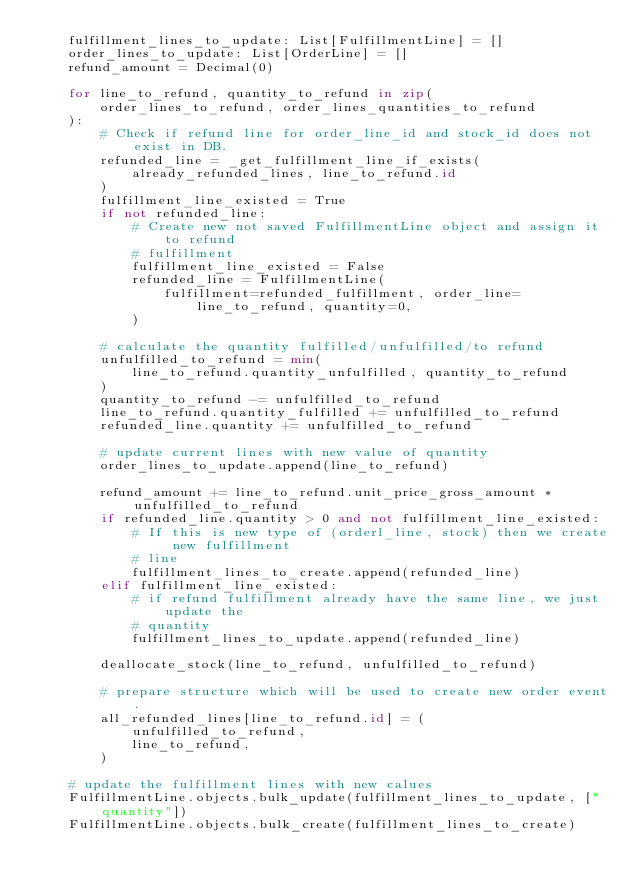<code> <loc_0><loc_0><loc_500><loc_500><_Python_>    fulfillment_lines_to_update: List[FulfillmentLine] = []
    order_lines_to_update: List[OrderLine] = []
    refund_amount = Decimal(0)

    for line_to_refund, quantity_to_refund in zip(
        order_lines_to_refund, order_lines_quantities_to_refund
    ):
        # Check if refund line for order_line_id and stock_id does not exist in DB.
        refunded_line = _get_fulfillment_line_if_exists(
            already_refunded_lines, line_to_refund.id
        )
        fulfillment_line_existed = True
        if not refunded_line:
            # Create new not saved FulfillmentLine object and assign it to refund
            # fulfillment
            fulfillment_line_existed = False
            refunded_line = FulfillmentLine(
                fulfillment=refunded_fulfillment, order_line=line_to_refund, quantity=0,
            )

        # calculate the quantity fulfilled/unfulfilled/to refund
        unfulfilled_to_refund = min(
            line_to_refund.quantity_unfulfilled, quantity_to_refund
        )
        quantity_to_refund -= unfulfilled_to_refund
        line_to_refund.quantity_fulfilled += unfulfilled_to_refund
        refunded_line.quantity += unfulfilled_to_refund

        # update current lines with new value of quantity
        order_lines_to_update.append(line_to_refund)

        refund_amount += line_to_refund.unit_price_gross_amount * unfulfilled_to_refund
        if refunded_line.quantity > 0 and not fulfillment_line_existed:
            # If this is new type of (orderl_line, stock) then we create new fulfillment
            # line
            fulfillment_lines_to_create.append(refunded_line)
        elif fulfillment_line_existed:
            # if refund fulfillment already have the same line, we just update the
            # quantity
            fulfillment_lines_to_update.append(refunded_line)

        deallocate_stock(line_to_refund, unfulfilled_to_refund)

        # prepare structure which will be used to create new order event.
        all_refunded_lines[line_to_refund.id] = (
            unfulfilled_to_refund,
            line_to_refund,
        )

    # update the fulfillment lines with new calues
    FulfillmentLine.objects.bulk_update(fulfillment_lines_to_update, ["quantity"])
    FulfillmentLine.objects.bulk_create(fulfillment_lines_to_create)</code> 